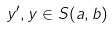Convert formula to latex. <formula><loc_0><loc_0><loc_500><loc_500>y ^ { \prime } , y \in S ( a , b )</formula> 